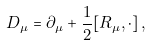<formula> <loc_0><loc_0><loc_500><loc_500>D _ { \mu } = \partial _ { \mu } + \frac { 1 } { 2 } [ R _ { \mu } , \cdot ] \, ,</formula> 